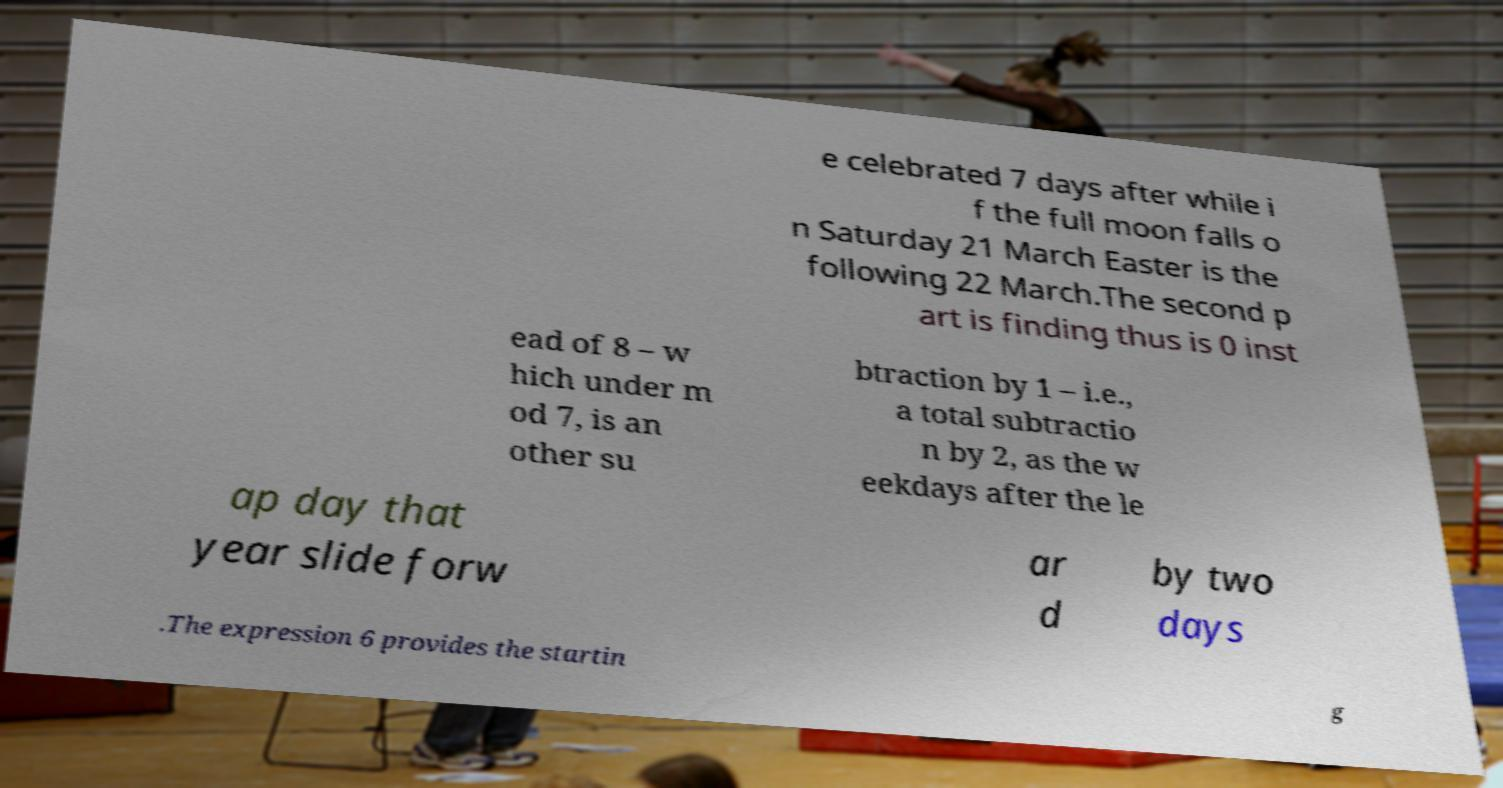For documentation purposes, I need the text within this image transcribed. Could you provide that? e celebrated 7 days after while i f the full moon falls o n Saturday 21 March Easter is the following 22 March.The second p art is finding thus is 0 inst ead of 8 – w hich under m od 7, is an other su btraction by 1 – i.e., a total subtractio n by 2, as the w eekdays after the le ap day that year slide forw ar d by two days .The expression 6 provides the startin g 